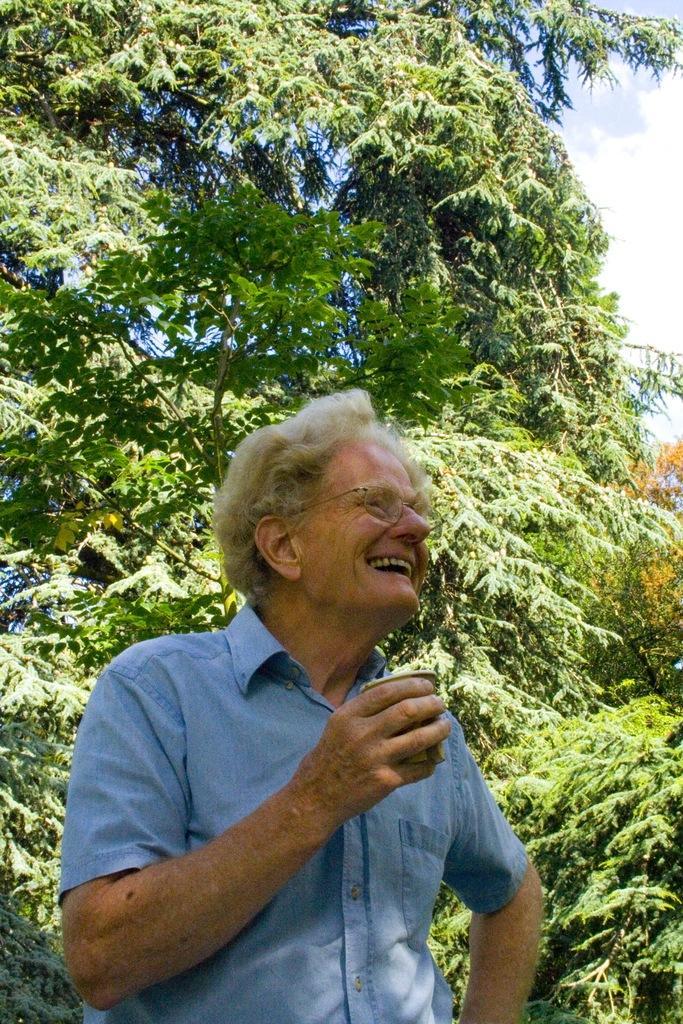Please provide a concise description of this image. In this picture I can see a man standing with a smile on his face and he is holding a glass in his hand and I can see trees and a blue cloudy sky. 